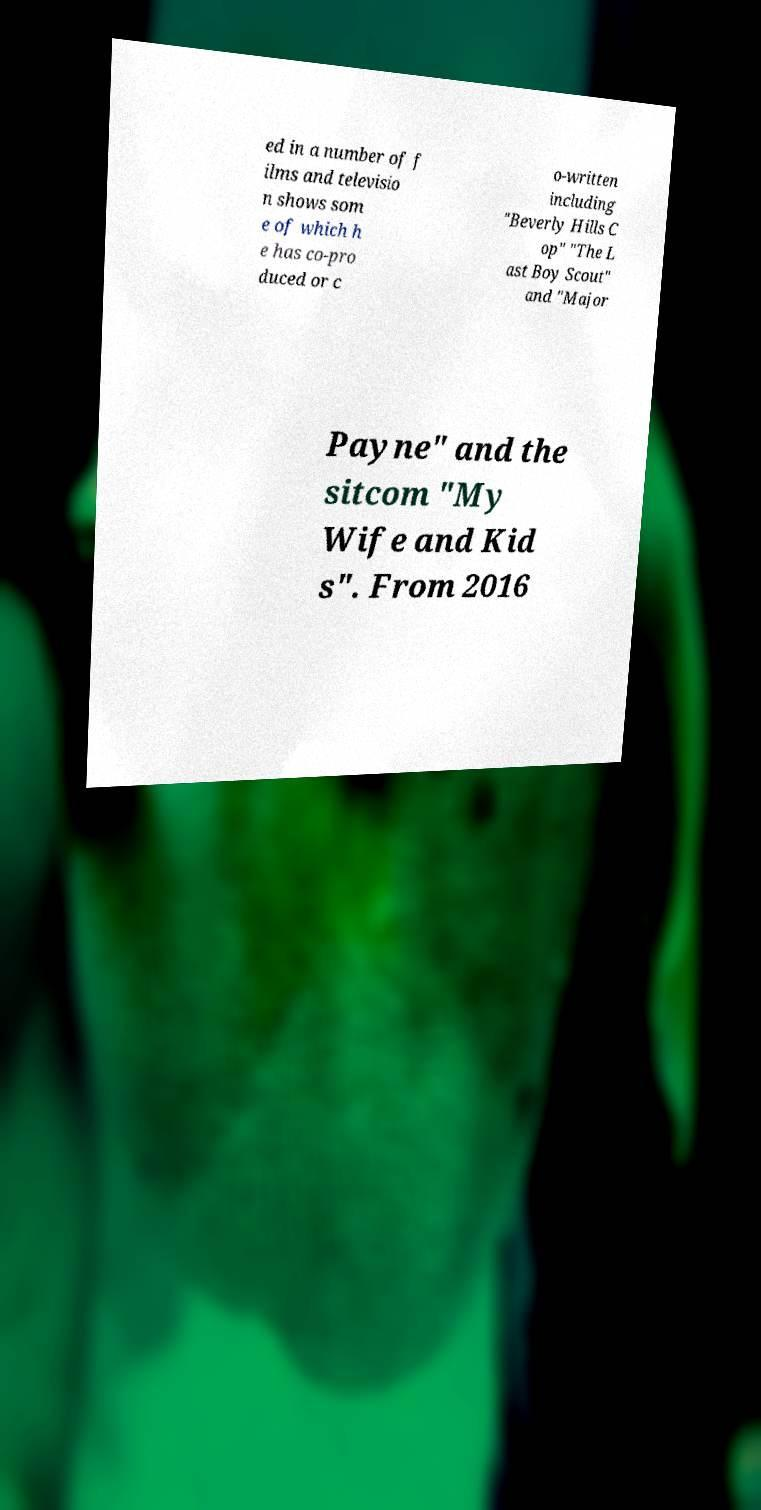What messages or text are displayed in this image? I need them in a readable, typed format. ed in a number of f ilms and televisio n shows som e of which h e has co-pro duced or c o-written including "Beverly Hills C op" "The L ast Boy Scout" and "Major Payne" and the sitcom "My Wife and Kid s". From 2016 